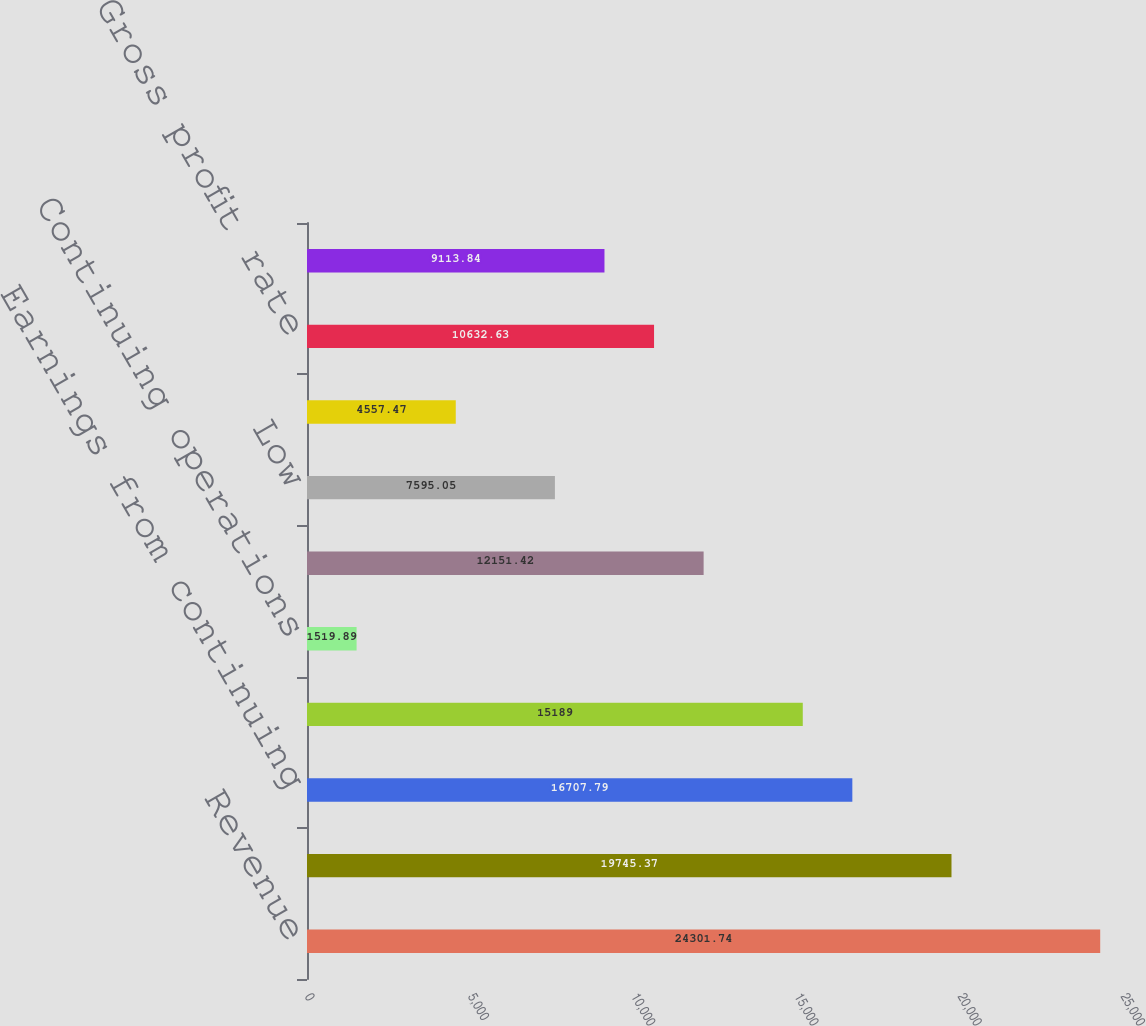<chart> <loc_0><loc_0><loc_500><loc_500><bar_chart><fcel>Revenue<fcel>Operating income<fcel>Earnings from continuing<fcel>Net earnings<fcel>Continuing operations<fcel>High<fcel>Low<fcel>Comparable store sales change<fcel>Gross profit rate<fcel>Selling general and<nl><fcel>24301.7<fcel>19745.4<fcel>16707.8<fcel>15189<fcel>1519.89<fcel>12151.4<fcel>7595.05<fcel>4557.47<fcel>10632.6<fcel>9113.84<nl></chart> 